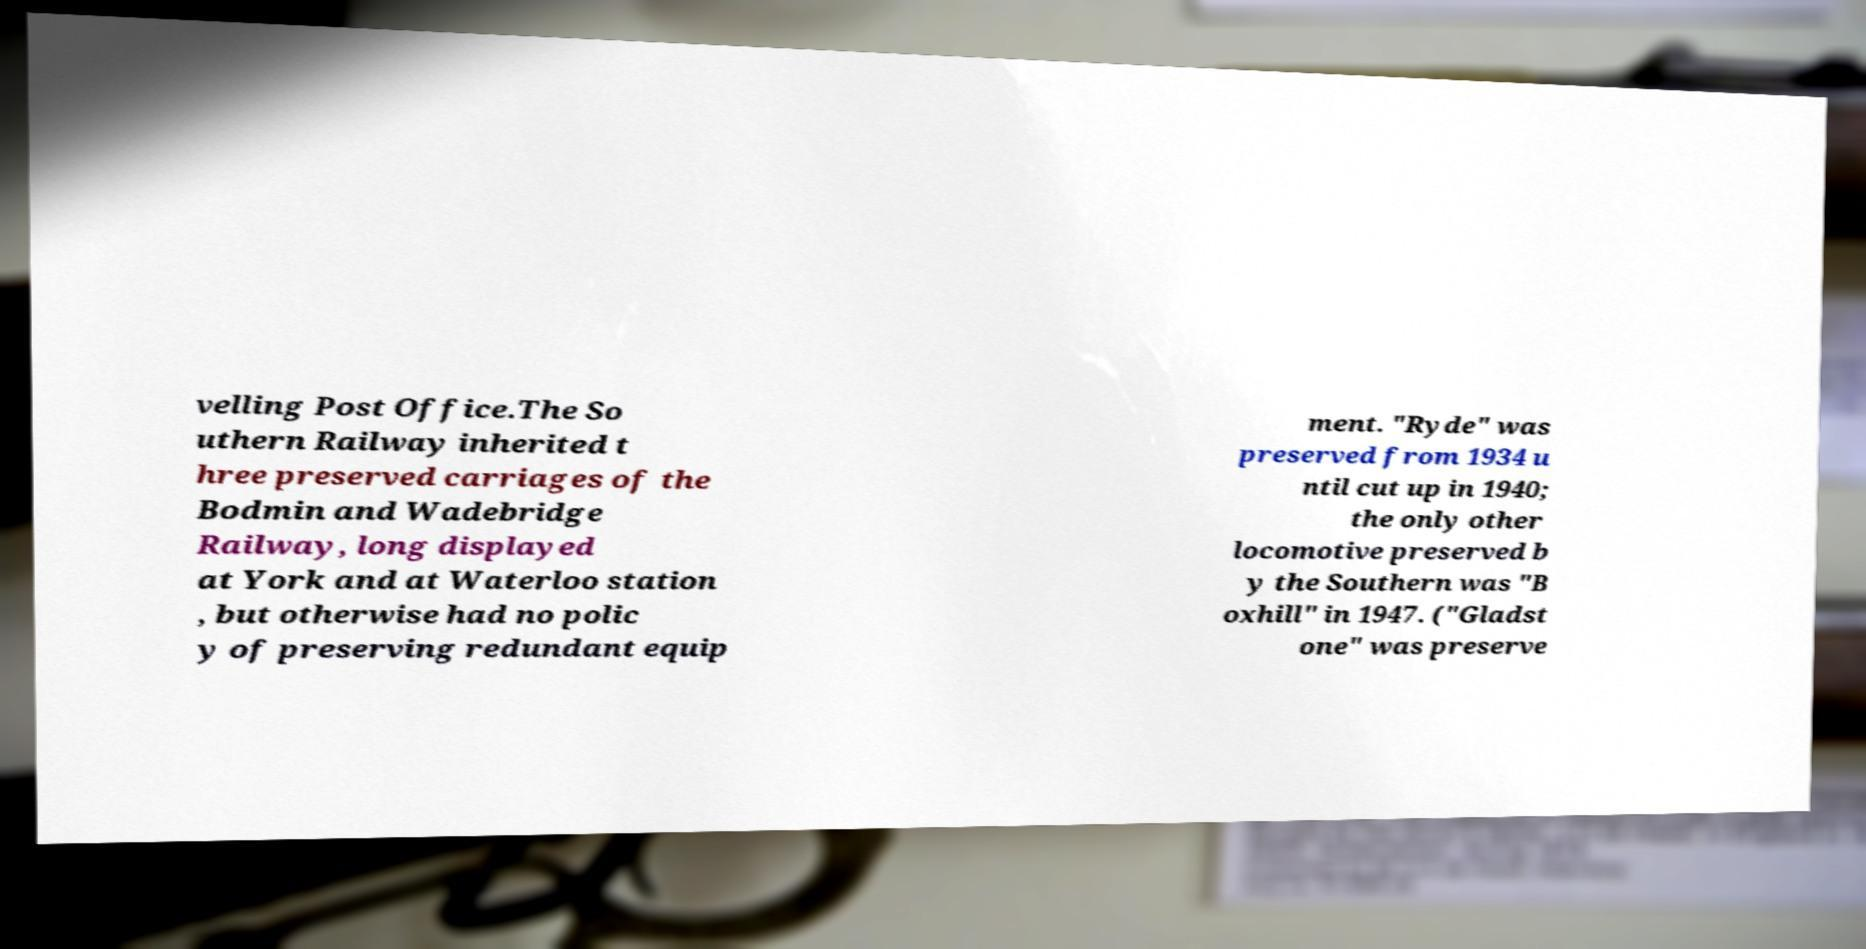There's text embedded in this image that I need extracted. Can you transcribe it verbatim? velling Post Office.The So uthern Railway inherited t hree preserved carriages of the Bodmin and Wadebridge Railway, long displayed at York and at Waterloo station , but otherwise had no polic y of preserving redundant equip ment. "Ryde" was preserved from 1934 u ntil cut up in 1940; the only other locomotive preserved b y the Southern was "B oxhill" in 1947. ("Gladst one" was preserve 